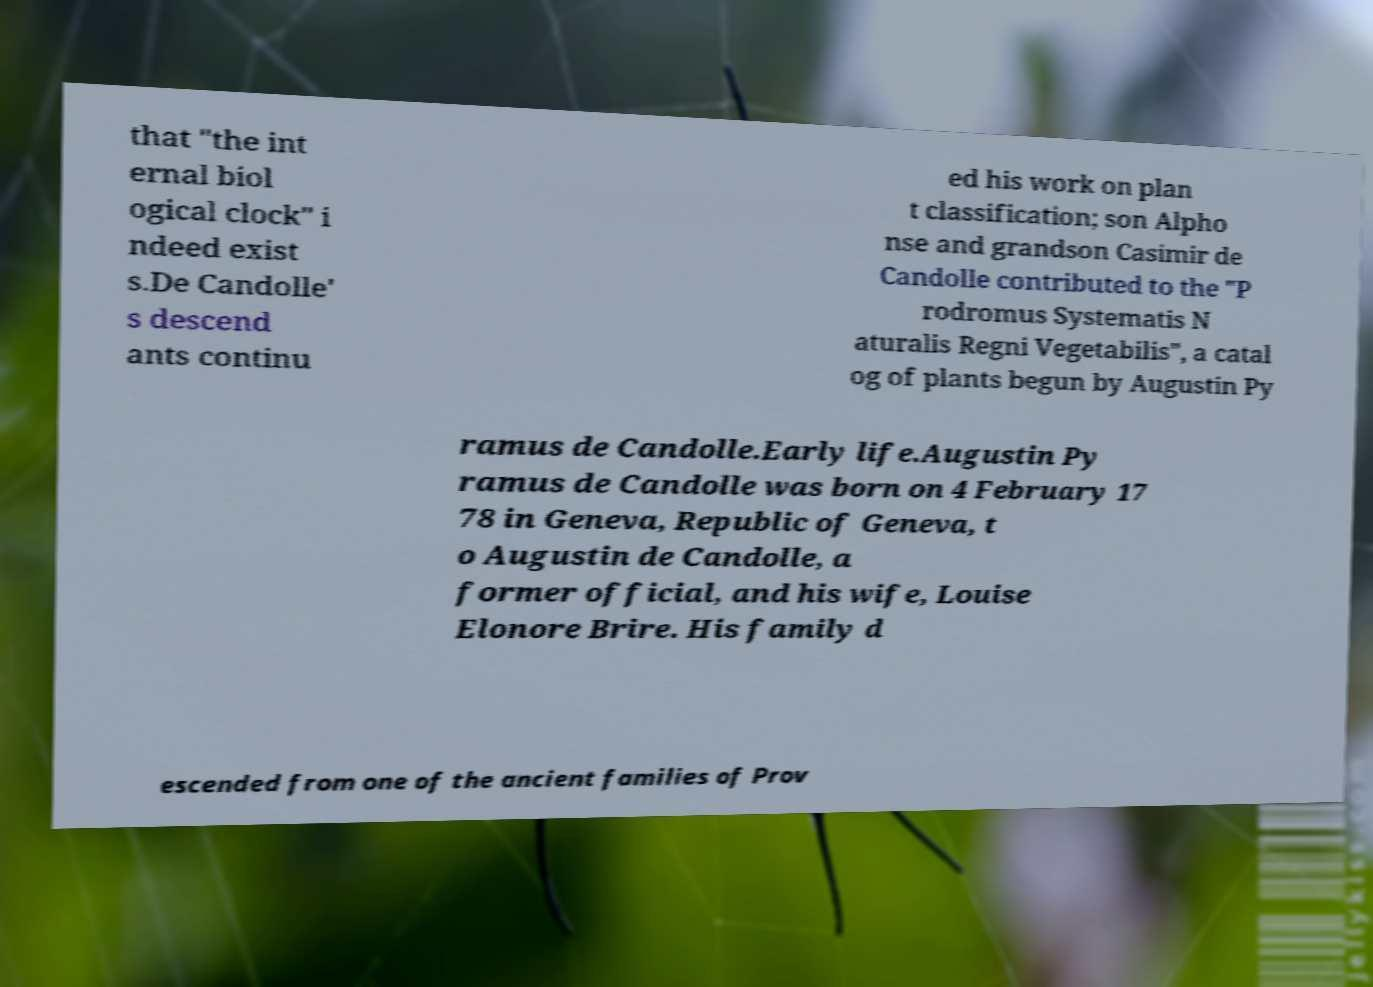Please identify and transcribe the text found in this image. that ″the int ernal biol ogical clock″ i ndeed exist s.De Candolle' s descend ants continu ed his work on plan t classification; son Alpho nse and grandson Casimir de Candolle contributed to the "P rodromus Systematis N aturalis Regni Vegetabilis", a catal og of plants begun by Augustin Py ramus de Candolle.Early life.Augustin Py ramus de Candolle was born on 4 February 17 78 in Geneva, Republic of Geneva, t o Augustin de Candolle, a former official, and his wife, Louise Elonore Brire. His family d escended from one of the ancient families of Prov 